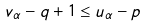<formula> <loc_0><loc_0><loc_500><loc_500>v _ { \alpha } - q + 1 \leq u _ { \alpha } - p</formula> 